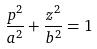<formula> <loc_0><loc_0><loc_500><loc_500>\frac { p ^ { 2 } } { a ^ { 2 } } + \frac { z ^ { 2 } } { b ^ { 2 } } = 1</formula> 